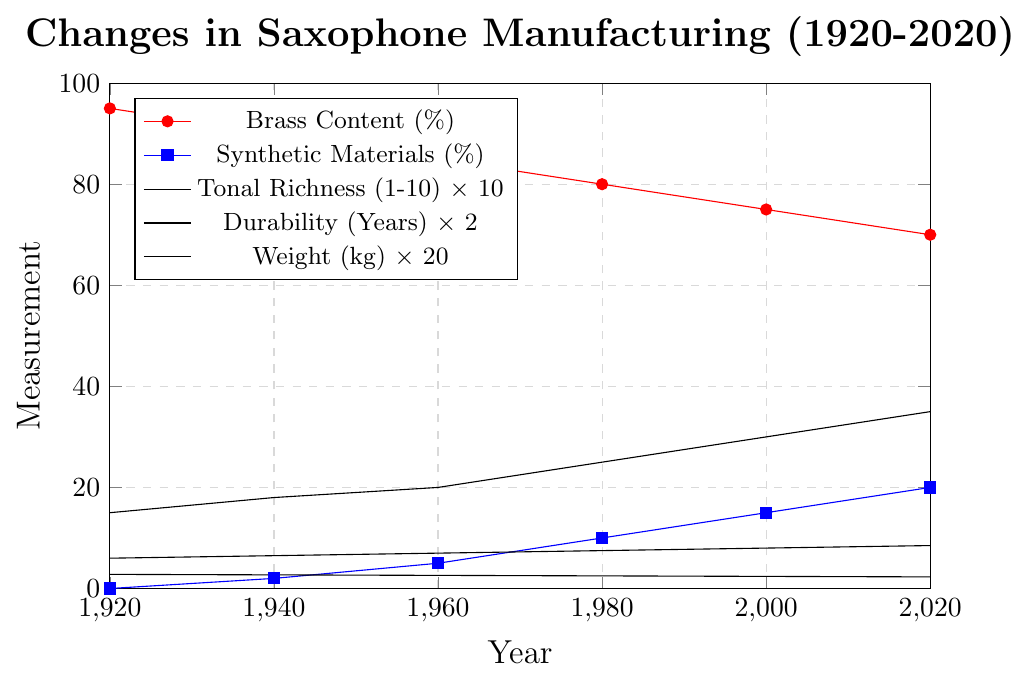What is the overall trend in the brass content percentage from 1920 to 2020? The brass content percentage consistently decreases over time. Starting from 95% in 1920, it declines gradually and reaches 70% in 2020.
Answer: Decreasing trend What is the difference in synthetic materials percentage between 1960 and 2000? In 1960, the synthetic materials percentage is 5%, while it increases to 15% by 2000. The difference is 15% - 5% = 10%.
Answer: 10% How does the tonal richness change from 1920 to 2020? The tonal richness increases gradually from 6 in 1920 to 8.5 in 2020. This shows an improvement in tonal richness over the century.
Answer: Increasing trend In which year does the durability of saxophones reach 25 years? The durability of saxophones reaches 25 years in 1980.  This can be deduced by looking for when the durability line reaches the corresponding mark.
Answer: 1980 Compare the weight of saxophones in 1920 and 2020. The weight of saxophones decreases from 2.8 kg in 1920 to 2.3 kg in 2020. This shows a reduction in weight over time.
Answer: Decreased What is the average durability of saxophones over the years provided? Sum the durability values for each year: 15 + 18 + 20 + 25 + 30 + 35 = 143. There are six years, so the average durability is 143 / 6 ≈ 23.83 years.
Answer: 23.83 years Which attribute shows the largest percentage change from 1920 to 2020? Calculate the percentage change for each attribute:
- Brass Content: ((95 - 70) / 95) * 100 ≈ 26.32%
- Synthetic Materials: ((20 - 0) / 0) * 100 = Infinity (as we start from 0)
- Tonal Richness: ((8.5 - 6) / 6) * 100 ≈ 41.67%
- Durability: ((35 - 15) / 15) * 100 ≈ 133.33%
- Weight: ((2.8 - 2.3) / 2.8) * 100 ≈ 17.86%
Synthetic Materials has the largest percentage change technically going from 0 to 20, but since starting from 0 might be debatable, next highest is Durability with 133.33%.
Answer: Durability or Synthetic Materials (if considering starting from zero) Which attribute has improved the most in terms of perceived quality changes over the century? Tonal richness improves from 6 to 8.5, indicating better quality in sound. Durability also improves significantly from 15 to 35 years, indicating better longevity, and synthetic materials' use increased. Consider qualitative improvements, either durability or tonal richness.
Answer: Tonal richness or durability How does the tonal richness in 1980 compare to the tonal richness in 1920? The tonal richness increases from 6 in 1920 to 7.5 in 1980, indicating a 1.5-point increase.
Answer: Increased What is the trend in synthetic materials usage over time? Synthetic materials usage starts at 0% in 1920 and gradually increases, reaching 20% by 2020. This shows a growing trend in the use of synthetic materials.
Answer: Increasing trend 